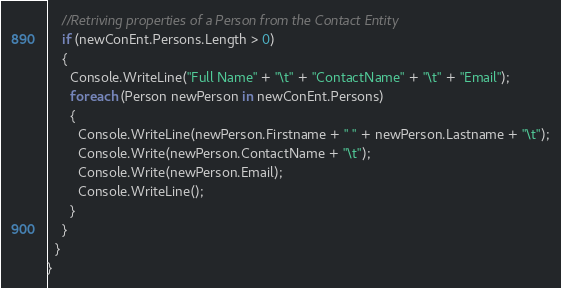<code> <loc_0><loc_0><loc_500><loc_500><_C#_>    //Retriving properties of a Person from the Contact Entity
    if (newConEnt.Persons.Length > 0)
    {
      Console.WriteLine("Full Name" + "\t" + "ContactName" + "\t" + "Email");
      foreach (Person newPerson in newConEnt.Persons)
      {
        Console.WriteLine(newPerson.Firstname + " " + newPerson.Lastname + "\t");
        Console.Write(newPerson.ContactName + "\t");
        Console.Write(newPerson.Email);
        Console.WriteLine();
      }
    }
  }
}</code> 